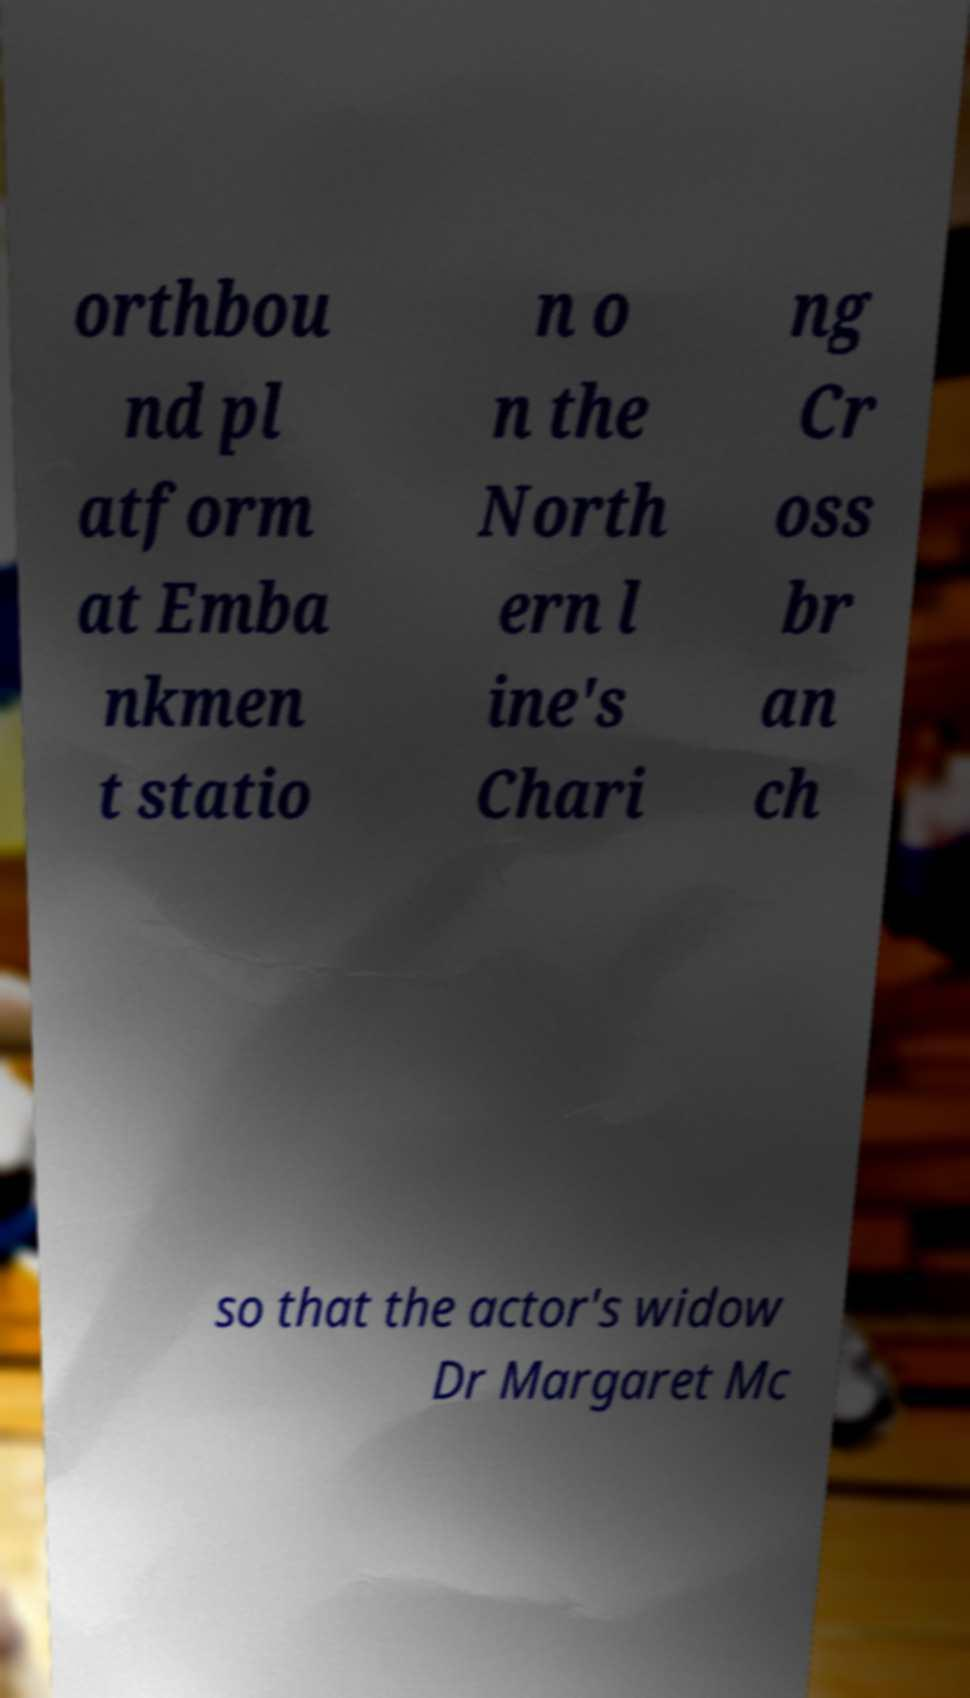Could you assist in decoding the text presented in this image and type it out clearly? orthbou nd pl atform at Emba nkmen t statio n o n the North ern l ine's Chari ng Cr oss br an ch so that the actor's widow Dr Margaret Mc 